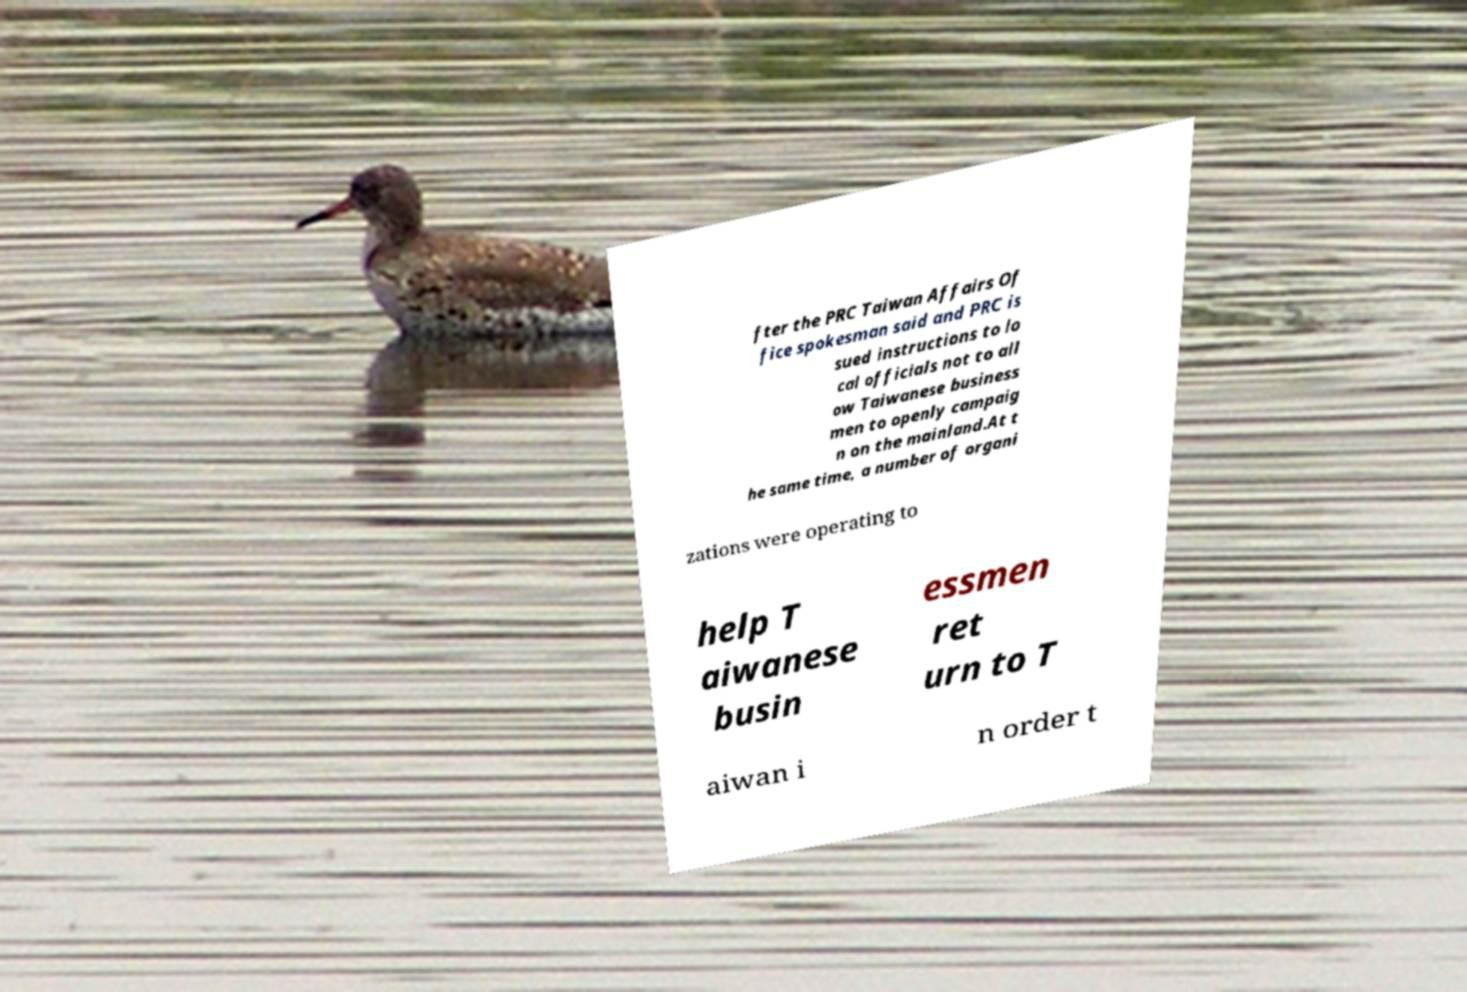Can you read and provide the text displayed in the image?This photo seems to have some interesting text. Can you extract and type it out for me? fter the PRC Taiwan Affairs Of fice spokesman said and PRC is sued instructions to lo cal officials not to all ow Taiwanese business men to openly campaig n on the mainland.At t he same time, a number of organi zations were operating to help T aiwanese busin essmen ret urn to T aiwan i n order t 